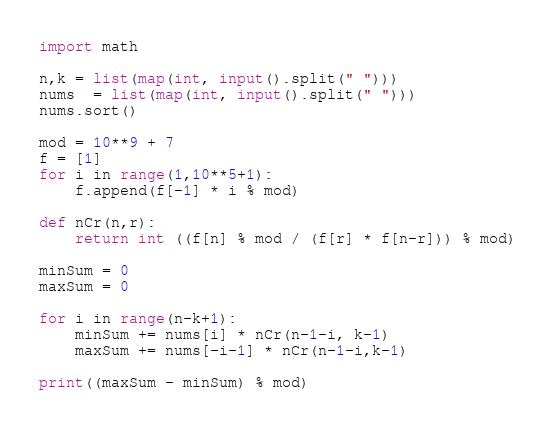Convert code to text. <code><loc_0><loc_0><loc_500><loc_500><_Python_>import math

n,k = list(map(int, input().split(" ")))
nums  = list(map(int, input().split(" ")))
nums.sort()

mod = 10**9 + 7
f = [1]
for i in range(1,10**5+1):
    f.append(f[-1] * i % mod)

def nCr(n,r):
    return int ((f[n] % mod / (f[r] * f[n-r])) % mod)

minSum = 0
maxSum = 0

for i in range(n-k+1):
    minSum += nums[i] * nCr(n-1-i, k-1)
    maxSum += nums[-i-1] * nCr(n-1-i,k-1)

print((maxSum - minSum) % mod)</code> 